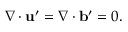<formula> <loc_0><loc_0><loc_500><loc_500>\nabla \cdot { u } ^ { \prime } = \nabla \cdot { b } ^ { \prime } = 0 .</formula> 